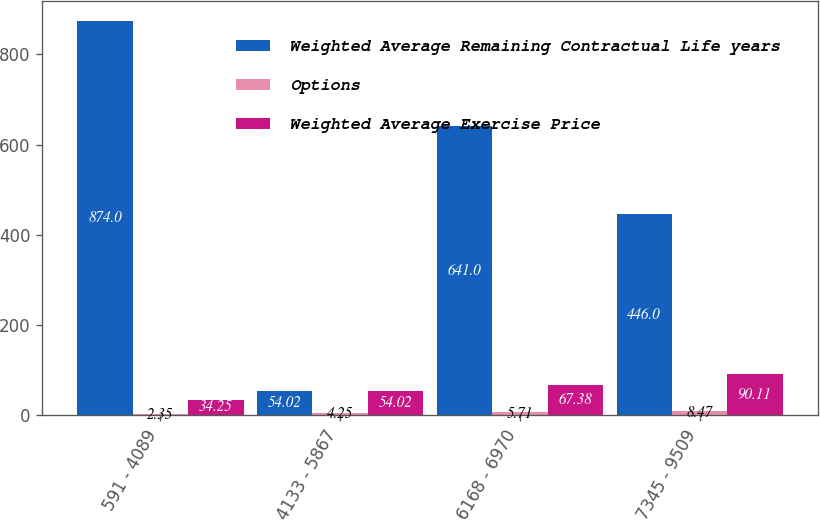<chart> <loc_0><loc_0><loc_500><loc_500><stacked_bar_chart><ecel><fcel>591 - 4089<fcel>4133 - 5867<fcel>6168 - 6970<fcel>7345 - 9509<nl><fcel>Weighted Average Remaining Contractual Life years<fcel>874<fcel>54.02<fcel>641<fcel>446<nl><fcel>Options<fcel>2.35<fcel>4.25<fcel>5.71<fcel>8.47<nl><fcel>Weighted Average Exercise Price<fcel>34.25<fcel>54.02<fcel>67.38<fcel>90.11<nl></chart> 